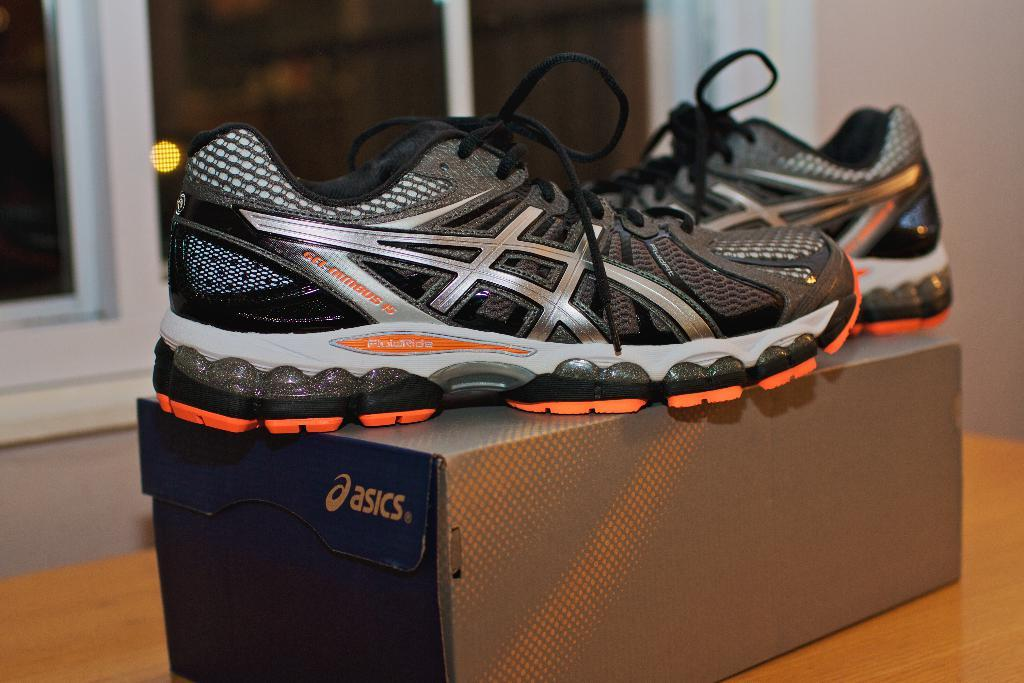What is placed on the box in the image? There is a pair of shoes on a box in the image. Where is the box located? The box is on a table in the image. What can be seen in the background of the image? There is a window, a curtain, and a wall in the background of the image. What type of cabbage is growing on the wall in the image? There is no cabbage present in the image; the wall is part of the background and does not have any plants or vegetables growing on it. 